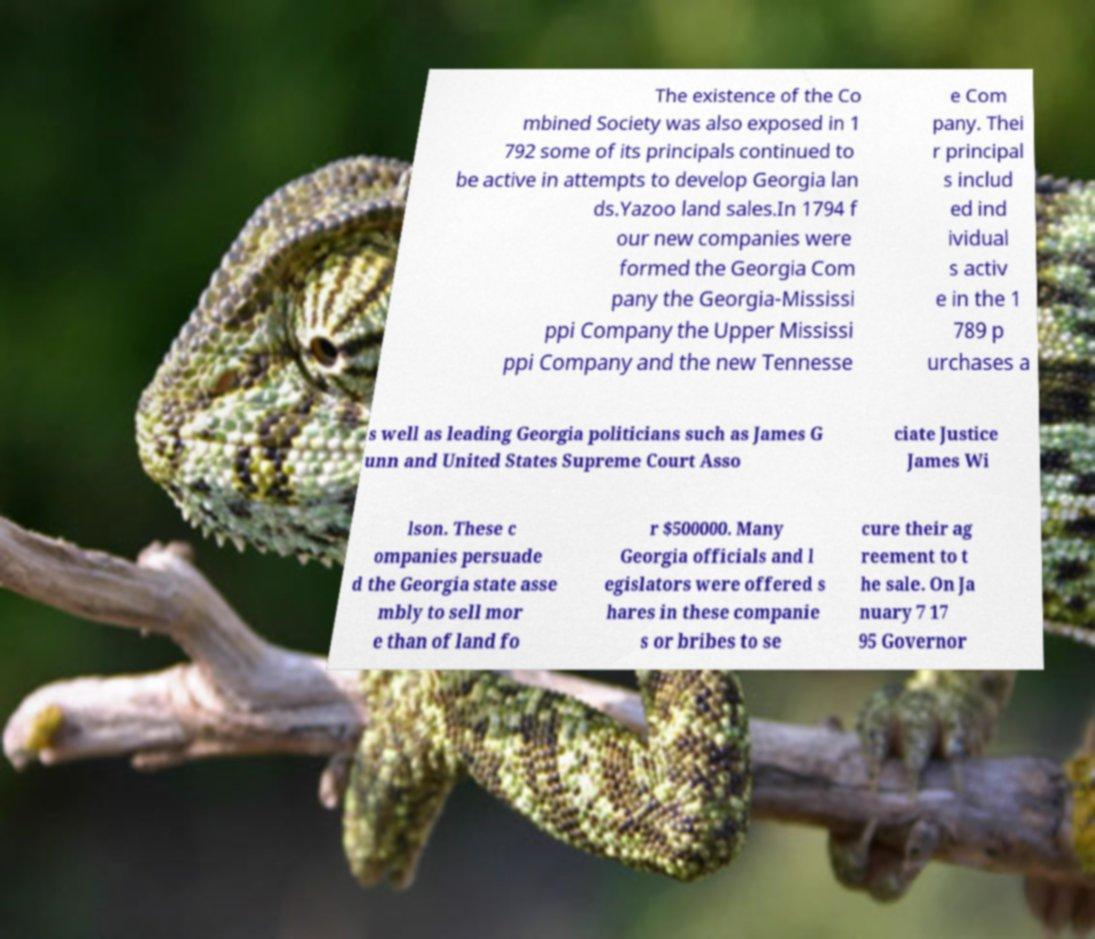I need the written content from this picture converted into text. Can you do that? The existence of the Co mbined Society was also exposed in 1 792 some of its principals continued to be active in attempts to develop Georgia lan ds.Yazoo land sales.In 1794 f our new companies were formed the Georgia Com pany the Georgia-Mississi ppi Company the Upper Mississi ppi Company and the new Tennesse e Com pany. Thei r principal s includ ed ind ividual s activ e in the 1 789 p urchases a s well as leading Georgia politicians such as James G unn and United States Supreme Court Asso ciate Justice James Wi lson. These c ompanies persuade d the Georgia state asse mbly to sell mor e than of land fo r $500000. Many Georgia officials and l egislators were offered s hares in these companie s or bribes to se cure their ag reement to t he sale. On Ja nuary 7 17 95 Governor 